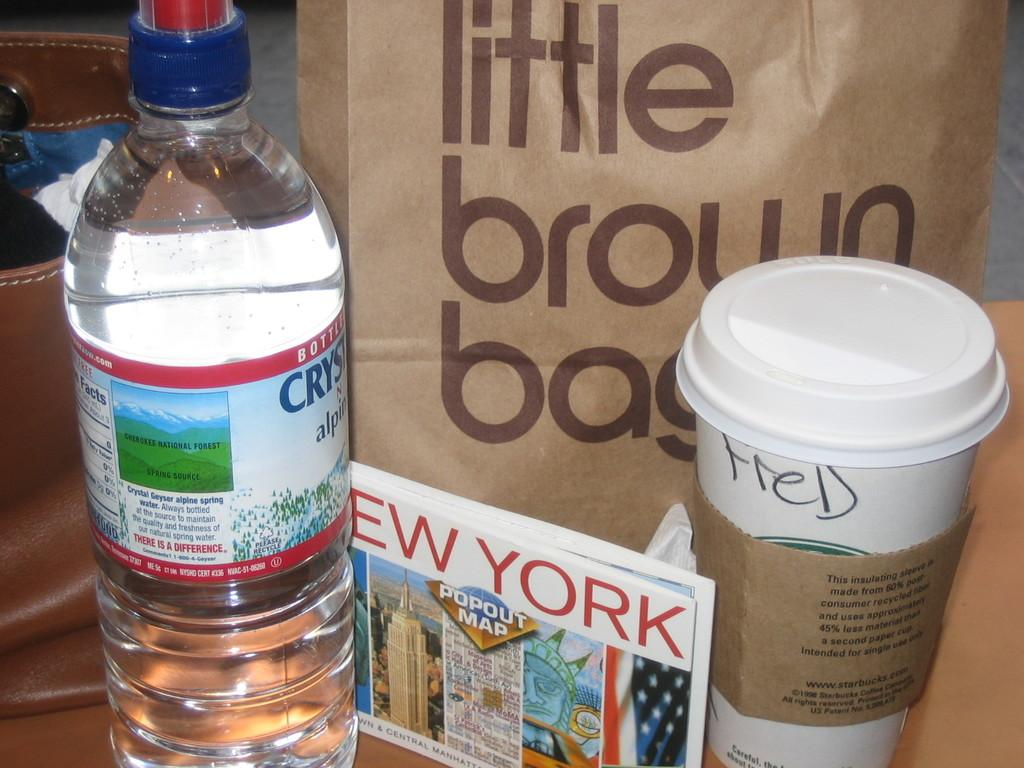Provide a one-sentence caption for the provided image. A bottle of water and coffee cup sit in front of a bag labeled "Little Brown Bag.". 